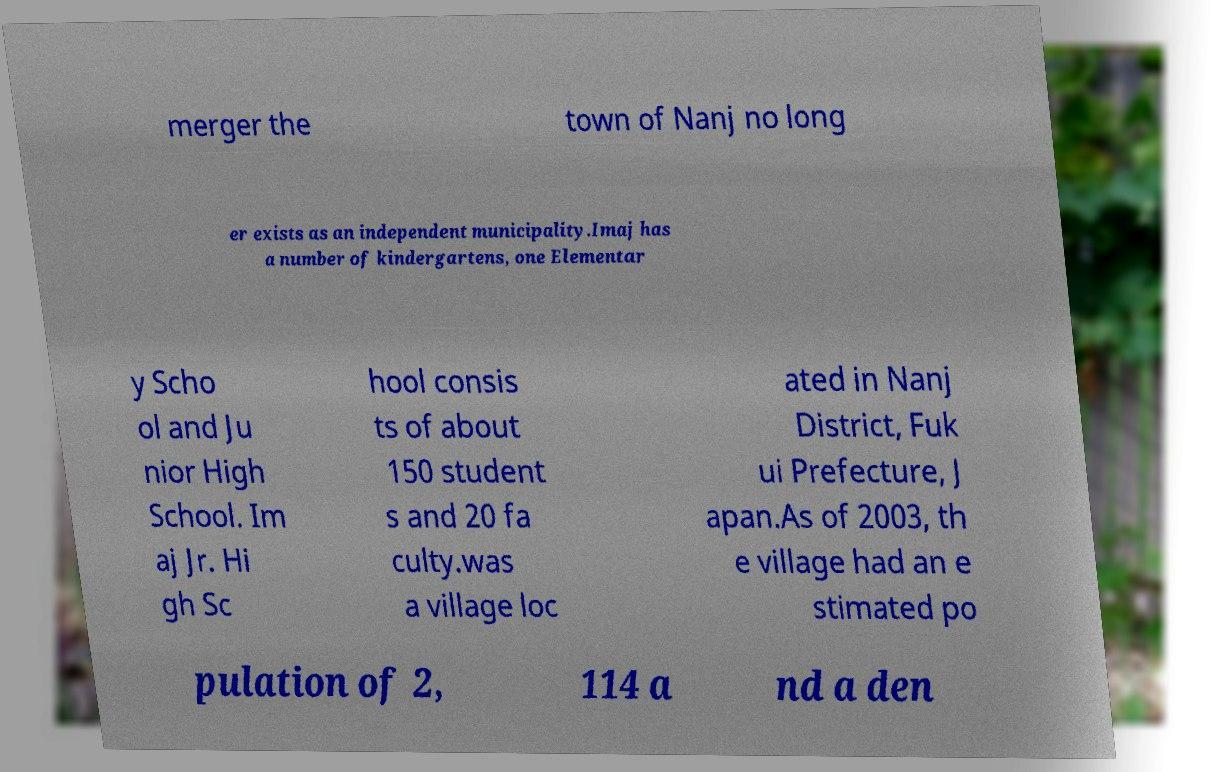Could you extract and type out the text from this image? merger the town of Nanj no long er exists as an independent municipality.Imaj has a number of kindergartens, one Elementar y Scho ol and Ju nior High School. Im aj Jr. Hi gh Sc hool consis ts of about 150 student s and 20 fa culty.was a village loc ated in Nanj District, Fuk ui Prefecture, J apan.As of 2003, th e village had an e stimated po pulation of 2, 114 a nd a den 